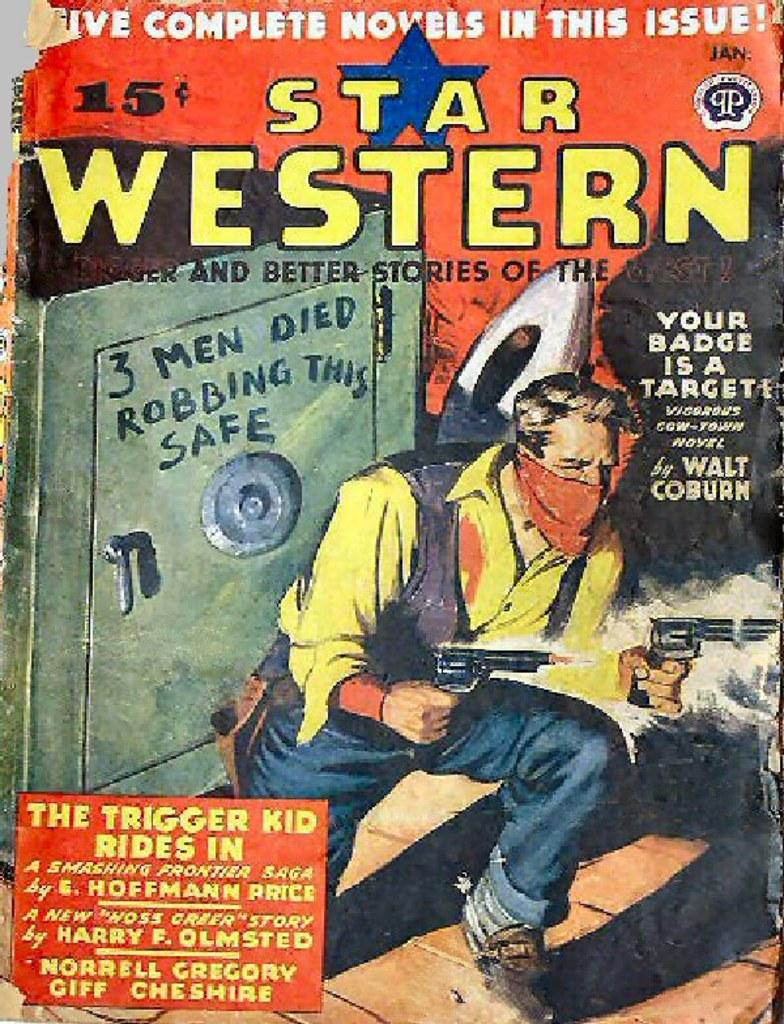<image>
Provide a brief description of the given image. Book cover showing a cowboy holding two guns titled Star Western. 